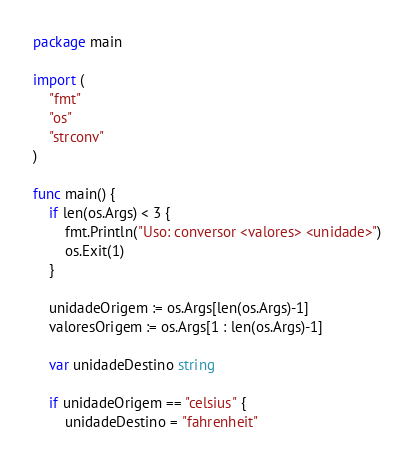Convert code to text. <code><loc_0><loc_0><loc_500><loc_500><_Go_>package main

import (
	"fmt"
	"os"
	"strconv"
)

func main() {
	if len(os.Args) < 3 {
		fmt.Println("Uso: conversor <valores> <unidade>")
		os.Exit(1)
	}

	unidadeOrigem := os.Args[len(os.Args)-1]
	valoresOrigem := os.Args[1 : len(os.Args)-1]

	var unidadeDestino string

	if unidadeOrigem == "celsius" {
		unidadeDestino = "fahrenheit"</code> 